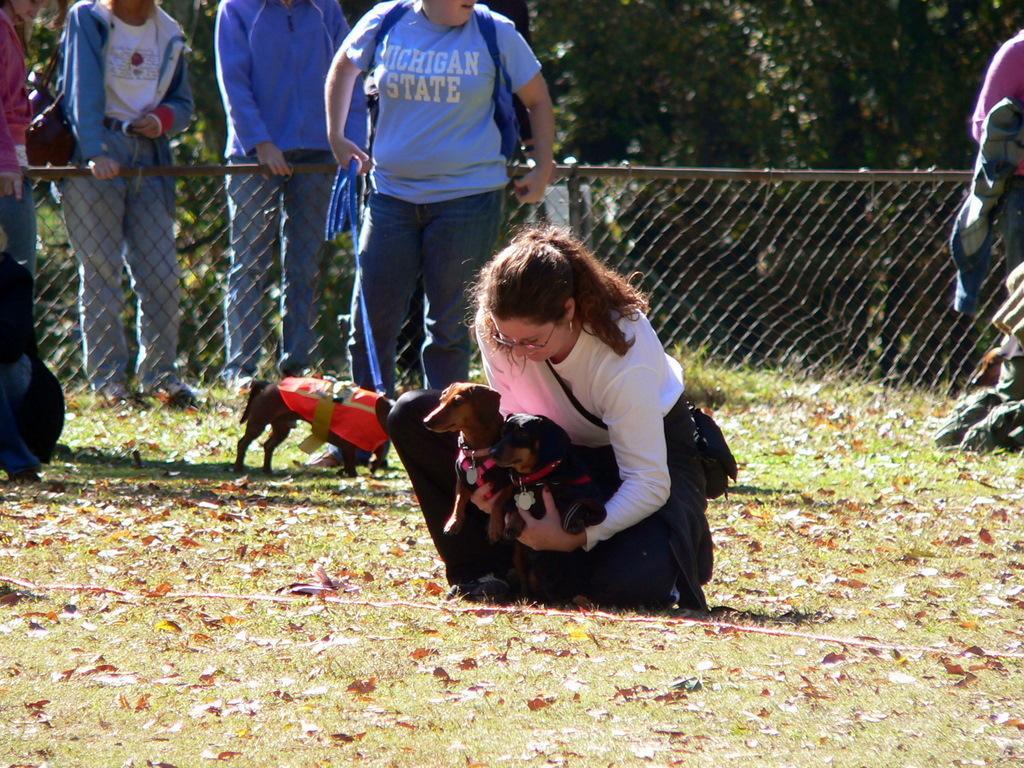Please provide a concise description of this image. In this picture there is a woman holding a dog with both the hands and they are a group of people standing on to the left there is also another dog over here and in the backdrop there are trees, fence and grass 